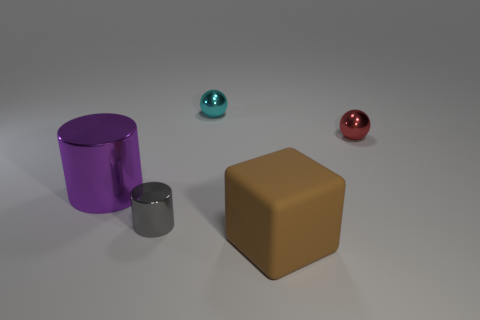There is a purple object that is the same shape as the gray metal thing; what is its size?
Ensure brevity in your answer.  Large. What number of big brown objects have the same material as the small gray object?
Keep it short and to the point. 0. There is a large metal cylinder; is it the same color as the tiny thing that is on the right side of the cube?
Keep it short and to the point. No. Is the number of tiny purple matte things greater than the number of shiny cylinders?
Offer a very short reply. No. What color is the block?
Provide a succinct answer. Brown. There is a metal thing that is in front of the purple object; is it the same shape as the large purple metal thing?
Your response must be concise. Yes. Is the number of large brown blocks on the right side of the big brown matte object less than the number of tiny shiny balls in front of the cyan shiny thing?
Ensure brevity in your answer.  Yes. What is the small ball that is on the left side of the small red metallic thing made of?
Ensure brevity in your answer.  Metal. Are there any cyan rubber cubes that have the same size as the red metal sphere?
Offer a terse response. No. Does the big brown matte thing have the same shape as the large thing that is behind the small gray shiny cylinder?
Offer a very short reply. No. 